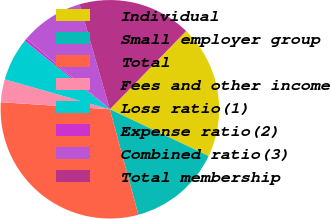<chart> <loc_0><loc_0><loc_500><loc_500><pie_chart><fcel>Individual<fcel>Small employer group<fcel>Total<fcel>Fees and other income<fcel>Loss ratio(1)<fcel>Expense ratio(2)<fcel>Combined ratio(3)<fcel>Total membership<nl><fcel>19.74%<fcel>13.77%<fcel>30.23%<fcel>3.39%<fcel>6.37%<fcel>0.4%<fcel>9.35%<fcel>16.75%<nl></chart> 